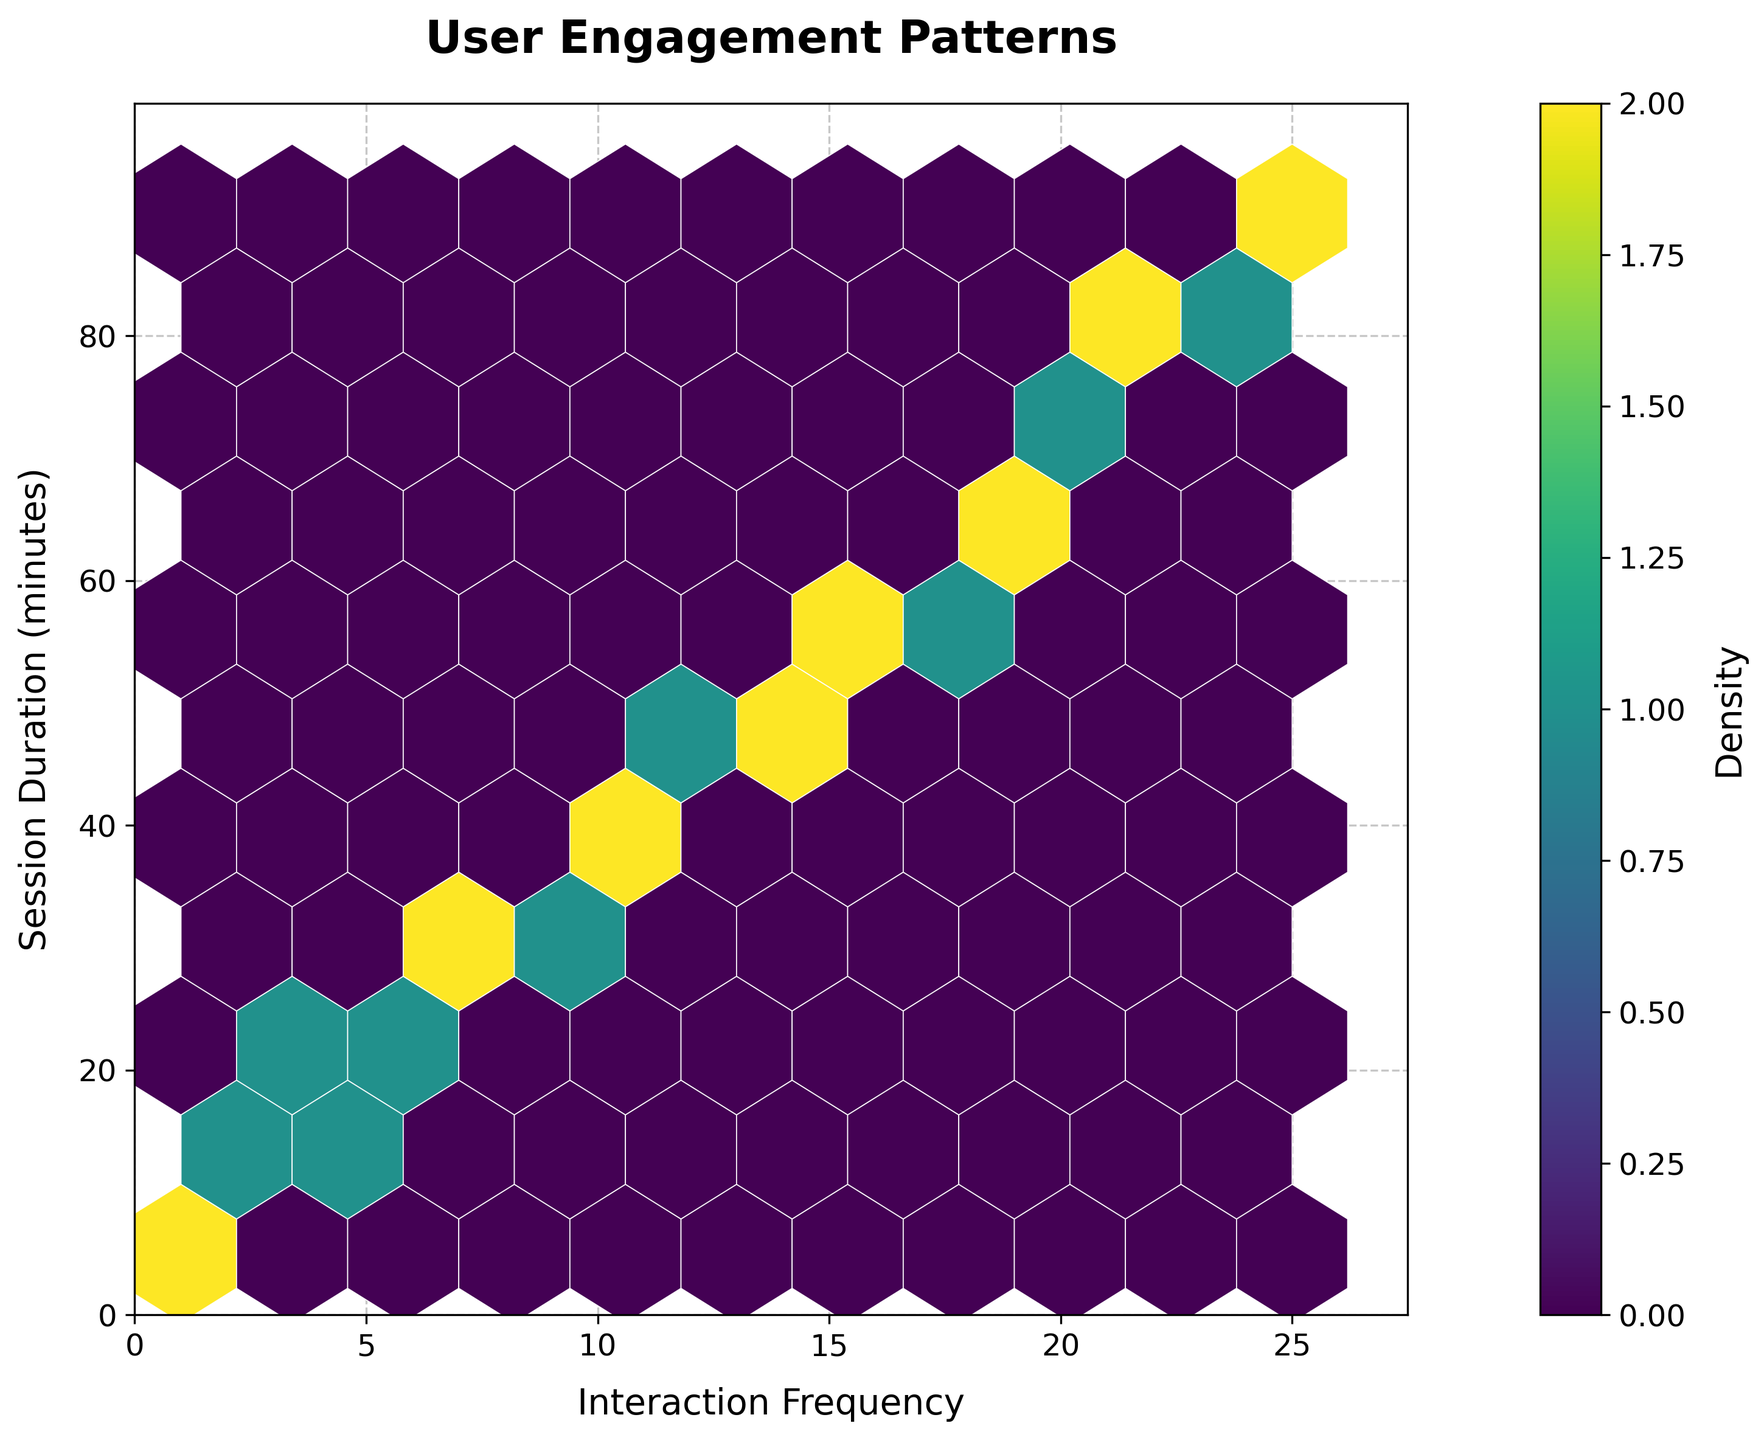what is the title of the figure? The title of a figure is usually displayed at the top and summarized in a large, bold text. From the description, the title is 'User Engagement Patterns'.
Answer: User Engagement Patterns what are the labels on the x and y axes? The x and y-axis labels are usually indicators of what the respective axes represent. According to the description, the x-axis label is 'Interaction Frequency' and the y-axis label is 'Session Duration (minutes)'.
Answer: Interaction Frequency and Session Duration (minutes) what color indicates the density in the hexbin plot? Hexbin plots color their hexagons to indicate varying densities. The description mentions a colormap 'viridis'. In 'viridis', the density scale typically goes from dark purple (low density) to yellow (high density).
Answer: viridis (from dark purple to yellow) what is the range of interaction frequencies shown in the plot? The interaction frequencies range from the minimum to the maximum value on the x-axis. Given the x-axis ranges from 0 to slightly more than 25 (to 'df['interaction_frequency'].max() * 1.1') based on description.
Answer: 0 to ~25 How does the session duration generally relate to interaction frequency? We look for the trend or pattern in the hexbin density. Higher densities closer to certain regions show general linkage. Higher interaction frequencies are concentrated around longer session durations, forming a positive correlation.
Answer: Positive correlation which region has the highest density of user interactions? The highest density is usually shown in the brightest color within the hexbin plot. Based on 'viridis' colormap, the brightest region represents the highest density.
Answer: Around interaction frequency of ~15 and session duration of ~60 minutes are there any high interaction frequencies but shorter session durations? Observing the hexbin plot for bright or dense regions in the right-most but lower sections of the plot indicates this pattern.
Answer: Very few or none what is the approximate maximum session duration for the plotted data? The y-axis limit is set to slightly more than 90 minutes. This is derived from using a factor of 1.1 on the maximum 'session_duration'.
Answer: ~90 minutes around what session durations do we see interaction frequencies peaking upwards of 20? By examining the x-values around 20+ and corresponding y-values with higher densities or brighter regions. Densities peak at session durations of ~75 to ~85 minutes.
Answer: ~75 to ~85 minutes 